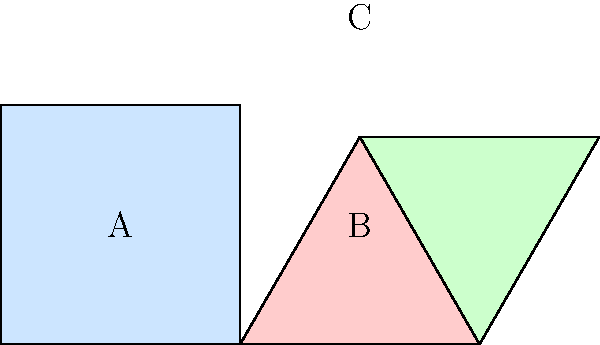In this tessellating pattern design, a square and two equilateral triangles are used. If the side length of the square is 60 units, what is the area of the region labeled ABC? Let's approach this step-by-step:

1) First, we need to recognize that ABC forms a 30-60-90 triangle.

2) In a 30-60-90 triangle, if the shortest side (opposite to the 30° angle) is x, then the hypotenuse is 2x, and the remaining side is $x\sqrt{3}$.

3) Here, AB is the side of the square, which is 60 units. This is the hypotenuse of our 30-60-90 triangle.

4) So, if the hypotenuse (AB) is 60, then the shortest side (BC) is 30, and AC is $30\sqrt{3}$.

5) Now we can calculate the area of triangle ABC using the formula:
   Area = $\frac{1}{2} \times base \times height$

6) We can use BC as the base (30) and the perpendicular height from A to BC.

7) This height is the same as half of AC: $\frac{30\sqrt{3}}{2} = 15\sqrt{3}$

8) Therefore, the area is:
   $$Area = \frac{1}{2} \times 30 \times 15\sqrt{3} = 225\sqrt{3}$$

9) Simplifying: $225\sqrt{3} \approx 389.71$ square units
Answer: $225\sqrt{3}$ square units 